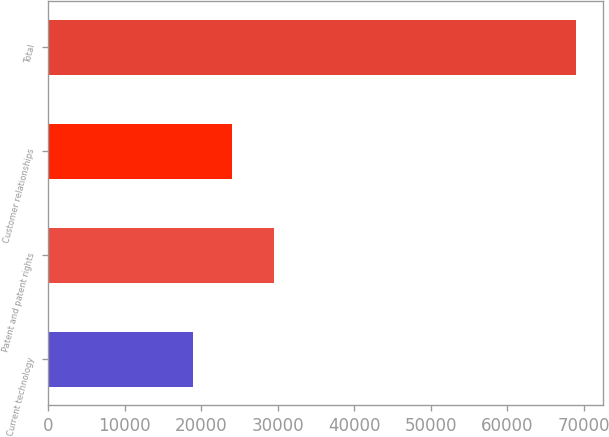Convert chart. <chart><loc_0><loc_0><loc_500><loc_500><bar_chart><fcel>Current technology<fcel>Patent and patent rights<fcel>Customer relationships<fcel>Total<nl><fcel>18978<fcel>29569<fcel>23984.2<fcel>69040<nl></chart> 